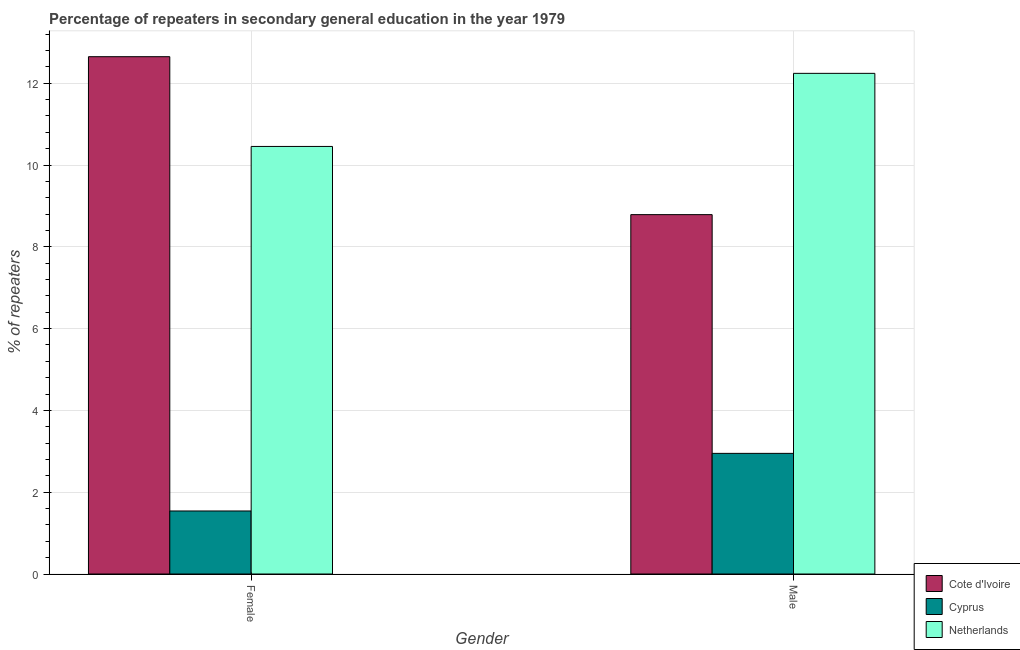How many different coloured bars are there?
Give a very brief answer. 3. Are the number of bars per tick equal to the number of legend labels?
Offer a terse response. Yes. How many bars are there on the 1st tick from the right?
Ensure brevity in your answer.  3. What is the percentage of female repeaters in Cote d'Ivoire?
Keep it short and to the point. 12.65. Across all countries, what is the maximum percentage of male repeaters?
Offer a very short reply. 12.24. Across all countries, what is the minimum percentage of female repeaters?
Keep it short and to the point. 1.54. In which country was the percentage of female repeaters minimum?
Offer a very short reply. Cyprus. What is the total percentage of female repeaters in the graph?
Ensure brevity in your answer.  24.64. What is the difference between the percentage of male repeaters in Cyprus and that in Cote d'Ivoire?
Provide a succinct answer. -5.84. What is the difference between the percentage of male repeaters in Cote d'Ivoire and the percentage of female repeaters in Cyprus?
Your response must be concise. 7.25. What is the average percentage of male repeaters per country?
Ensure brevity in your answer.  7.99. What is the difference between the percentage of male repeaters and percentage of female repeaters in Netherlands?
Provide a short and direct response. 1.79. What is the ratio of the percentage of female repeaters in Cote d'Ivoire to that in Netherlands?
Your answer should be compact. 1.21. In how many countries, is the percentage of male repeaters greater than the average percentage of male repeaters taken over all countries?
Your answer should be compact. 2. What does the 2nd bar from the left in Male represents?
Offer a terse response. Cyprus. What does the 2nd bar from the right in Female represents?
Give a very brief answer. Cyprus. How many countries are there in the graph?
Ensure brevity in your answer.  3. What is the difference between two consecutive major ticks on the Y-axis?
Offer a very short reply. 2. Does the graph contain any zero values?
Make the answer very short. No. Does the graph contain grids?
Provide a succinct answer. Yes. How many legend labels are there?
Ensure brevity in your answer.  3. What is the title of the graph?
Keep it short and to the point. Percentage of repeaters in secondary general education in the year 1979. Does "Rwanda" appear as one of the legend labels in the graph?
Make the answer very short. No. What is the label or title of the X-axis?
Offer a terse response. Gender. What is the label or title of the Y-axis?
Offer a very short reply. % of repeaters. What is the % of repeaters of Cote d'Ivoire in Female?
Keep it short and to the point. 12.65. What is the % of repeaters of Cyprus in Female?
Your answer should be compact. 1.54. What is the % of repeaters of Netherlands in Female?
Offer a terse response. 10.45. What is the % of repeaters of Cote d'Ivoire in Male?
Keep it short and to the point. 8.79. What is the % of repeaters in Cyprus in Male?
Provide a short and direct response. 2.95. What is the % of repeaters in Netherlands in Male?
Ensure brevity in your answer.  12.24. Across all Gender, what is the maximum % of repeaters of Cote d'Ivoire?
Offer a terse response. 12.65. Across all Gender, what is the maximum % of repeaters in Cyprus?
Your response must be concise. 2.95. Across all Gender, what is the maximum % of repeaters of Netherlands?
Keep it short and to the point. 12.24. Across all Gender, what is the minimum % of repeaters in Cote d'Ivoire?
Your answer should be compact. 8.79. Across all Gender, what is the minimum % of repeaters of Cyprus?
Keep it short and to the point. 1.54. Across all Gender, what is the minimum % of repeaters of Netherlands?
Your response must be concise. 10.45. What is the total % of repeaters of Cote d'Ivoire in the graph?
Your response must be concise. 21.43. What is the total % of repeaters in Cyprus in the graph?
Your answer should be compact. 4.49. What is the total % of repeaters in Netherlands in the graph?
Your answer should be compact. 22.69. What is the difference between the % of repeaters of Cote d'Ivoire in Female and that in Male?
Offer a terse response. 3.86. What is the difference between the % of repeaters in Cyprus in Female and that in Male?
Your answer should be compact. -1.41. What is the difference between the % of repeaters of Netherlands in Female and that in Male?
Your response must be concise. -1.79. What is the difference between the % of repeaters in Cote d'Ivoire in Female and the % of repeaters in Cyprus in Male?
Provide a short and direct response. 9.7. What is the difference between the % of repeaters in Cote d'Ivoire in Female and the % of repeaters in Netherlands in Male?
Give a very brief answer. 0.41. What is the difference between the % of repeaters of Cyprus in Female and the % of repeaters of Netherlands in Male?
Your answer should be very brief. -10.7. What is the average % of repeaters of Cote d'Ivoire per Gender?
Offer a terse response. 10.72. What is the average % of repeaters in Cyprus per Gender?
Your answer should be very brief. 2.25. What is the average % of repeaters of Netherlands per Gender?
Offer a terse response. 11.35. What is the difference between the % of repeaters of Cote d'Ivoire and % of repeaters of Cyprus in Female?
Your answer should be compact. 11.11. What is the difference between the % of repeaters of Cote d'Ivoire and % of repeaters of Netherlands in Female?
Keep it short and to the point. 2.19. What is the difference between the % of repeaters of Cyprus and % of repeaters of Netherlands in Female?
Give a very brief answer. -8.91. What is the difference between the % of repeaters of Cote d'Ivoire and % of repeaters of Cyprus in Male?
Keep it short and to the point. 5.84. What is the difference between the % of repeaters of Cote d'Ivoire and % of repeaters of Netherlands in Male?
Your response must be concise. -3.45. What is the difference between the % of repeaters in Cyprus and % of repeaters in Netherlands in Male?
Offer a very short reply. -9.29. What is the ratio of the % of repeaters of Cote d'Ivoire in Female to that in Male?
Provide a short and direct response. 1.44. What is the ratio of the % of repeaters of Cyprus in Female to that in Male?
Your answer should be very brief. 0.52. What is the ratio of the % of repeaters of Netherlands in Female to that in Male?
Your answer should be very brief. 0.85. What is the difference between the highest and the second highest % of repeaters of Cote d'Ivoire?
Your answer should be very brief. 3.86. What is the difference between the highest and the second highest % of repeaters of Cyprus?
Provide a short and direct response. 1.41. What is the difference between the highest and the second highest % of repeaters of Netherlands?
Your answer should be very brief. 1.79. What is the difference between the highest and the lowest % of repeaters of Cote d'Ivoire?
Keep it short and to the point. 3.86. What is the difference between the highest and the lowest % of repeaters of Cyprus?
Offer a very short reply. 1.41. What is the difference between the highest and the lowest % of repeaters in Netherlands?
Offer a very short reply. 1.79. 